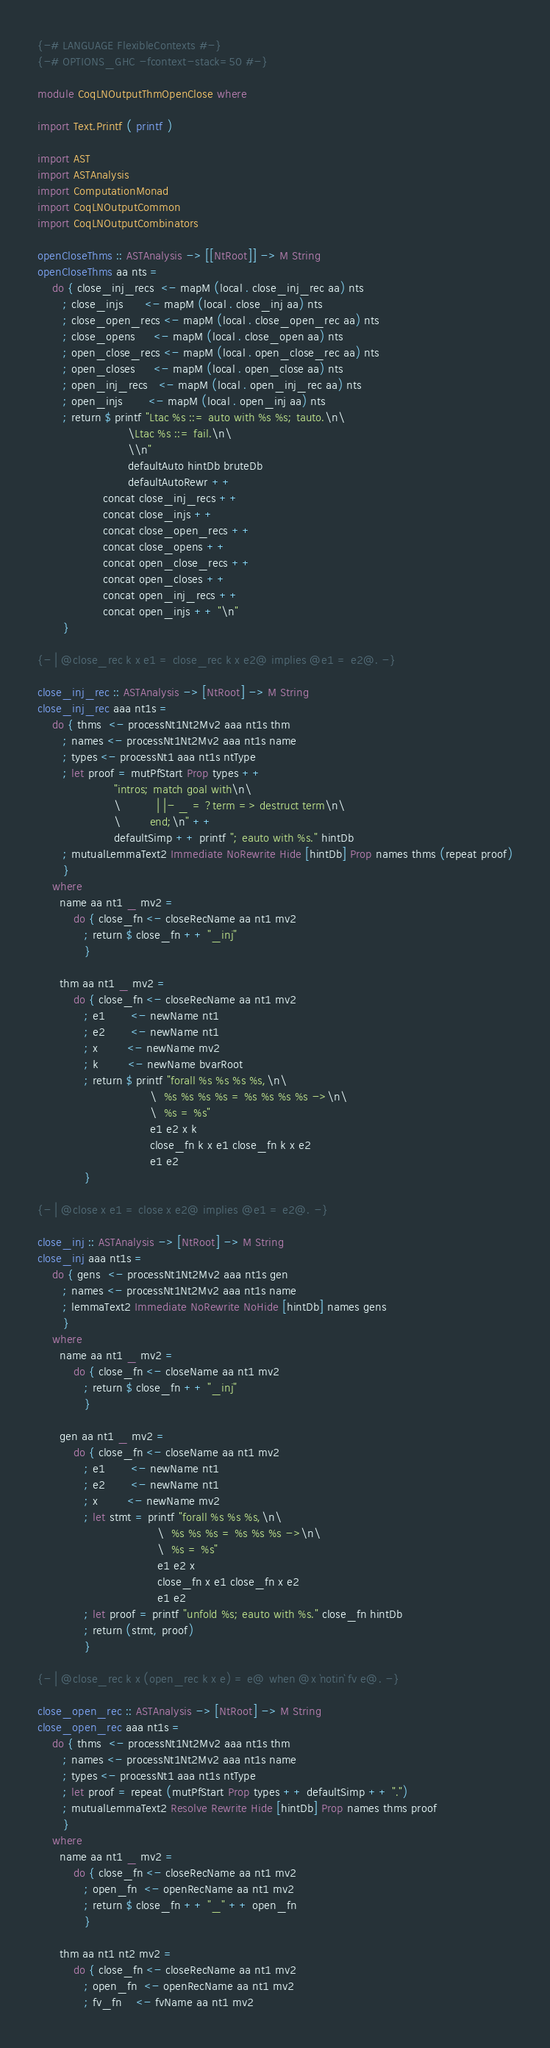<code> <loc_0><loc_0><loc_500><loc_500><_Haskell_>{-# LANGUAGE FlexibleContexts #-}
{-# OPTIONS_GHC -fcontext-stack=50 #-}

module CoqLNOutputThmOpenClose where

import Text.Printf ( printf )

import AST
import ASTAnalysis
import ComputationMonad
import CoqLNOutputCommon
import CoqLNOutputCombinators

openCloseThms :: ASTAnalysis -> [[NtRoot]] -> M String
openCloseThms aa nts =
    do { close_inj_recs  <- mapM (local . close_inj_rec aa) nts
       ; close_injs      <- mapM (local . close_inj aa) nts
       ; close_open_recs <- mapM (local . close_open_rec aa) nts
       ; close_opens     <- mapM (local . close_open aa) nts
       ; open_close_recs <- mapM (local . open_close_rec aa) nts
       ; open_closes     <- mapM (local . open_close aa) nts
       ; open_inj_recs   <- mapM (local . open_inj_rec aa) nts
       ; open_injs       <- mapM (local . open_inj aa) nts
       ; return $ printf "Ltac %s ::= auto with %s %s; tauto.\n\
                         \Ltac %s ::= fail.\n\
                         \\n"
                         defaultAuto hintDb bruteDb
                         defaultAutoRewr ++
                  concat close_inj_recs ++
                  concat close_injs ++
                  concat close_open_recs ++
                  concat close_opens ++
                  concat open_close_recs ++
                  concat open_closes ++
                  concat open_inj_recs ++
                  concat open_injs ++ "\n"
       }

{- | @close_rec k x e1 = close_rec k x e2@ implies @e1 = e2@. -}

close_inj_rec :: ASTAnalysis -> [NtRoot] -> M String
close_inj_rec aaa nt1s =
    do { thms  <- processNt1Nt2Mv2 aaa nt1s thm
       ; names <- processNt1Nt2Mv2 aaa nt1s name
       ; types <- processNt1 aaa nt1s ntType
       ; let proof = mutPfStart Prop types ++
                     "intros; match goal with\n\
                     \          | |- _ = ?term => destruct term\n\
                     \        end;\n" ++
                     defaultSimp ++ printf "; eauto with %s." hintDb
       ; mutualLemmaText2 Immediate NoRewrite Hide [hintDb] Prop names thms (repeat proof)
       }
    where
      name aa nt1 _ mv2 =
          do { close_fn <- closeRecName aa nt1 mv2
             ; return $ close_fn ++ "_inj"
             }

      thm aa nt1 _ mv2 =
          do { close_fn <- closeRecName aa nt1 mv2
             ; e1       <- newName nt1
             ; e2       <- newName nt1
             ; x        <- newName mv2
             ; k        <- newName bvarRoot
             ; return $ printf "forall %s %s %s %s,\n\
                               \  %s %s %s %s = %s %s %s %s ->\n\
                               \  %s = %s"
                               e1 e2 x k
                               close_fn k x e1 close_fn k x e2
                               e1 e2
             }

{- | @close x e1 = close x e2@ implies @e1 = e2@. -}

close_inj :: ASTAnalysis -> [NtRoot] -> M String
close_inj aaa nt1s =
    do { gens  <- processNt1Nt2Mv2 aaa nt1s gen
       ; names <- processNt1Nt2Mv2 aaa nt1s name
       ; lemmaText2 Immediate NoRewrite NoHide [hintDb] names gens
       }
    where
      name aa nt1 _ mv2 =
          do { close_fn <- closeName aa nt1 mv2
             ; return $ close_fn ++ "_inj"
             }

      gen aa nt1 _ mv2 =
          do { close_fn <- closeName aa nt1 mv2
             ; e1       <- newName nt1
             ; e2       <- newName nt1
             ; x        <- newName mv2
             ; let stmt = printf "forall %s %s %s,\n\
                                 \  %s %s %s = %s %s %s ->\n\
                                 \  %s = %s"
                                 e1 e2 x
                                 close_fn x e1 close_fn x e2
                                 e1 e2
             ; let proof = printf "unfold %s; eauto with %s." close_fn hintDb
             ; return (stmt, proof)
             }

{- | @close_rec k x (open_rec k x e) = e@ when @x `notin` fv e@. -}

close_open_rec :: ASTAnalysis -> [NtRoot] -> M String
close_open_rec aaa nt1s =
    do { thms  <- processNt1Nt2Mv2 aaa nt1s thm
       ; names <- processNt1Nt2Mv2 aaa nt1s name
       ; types <- processNt1 aaa nt1s ntType
       ; let proof = repeat (mutPfStart Prop types ++ defaultSimp ++ ".")
       ; mutualLemmaText2 Resolve Rewrite Hide [hintDb] Prop names thms proof
       }
    where
      name aa nt1 _ mv2 =
          do { close_fn <- closeRecName aa nt1 mv2
             ; open_fn  <- openRecName aa nt1 mv2
             ; return $ close_fn ++ "_" ++ open_fn
             }

      thm aa nt1 nt2 mv2 =
          do { close_fn <- closeRecName aa nt1 mv2
             ; open_fn  <- openRecName aa nt1 mv2
             ; fv_fn    <- fvName aa nt1 mv2</code> 